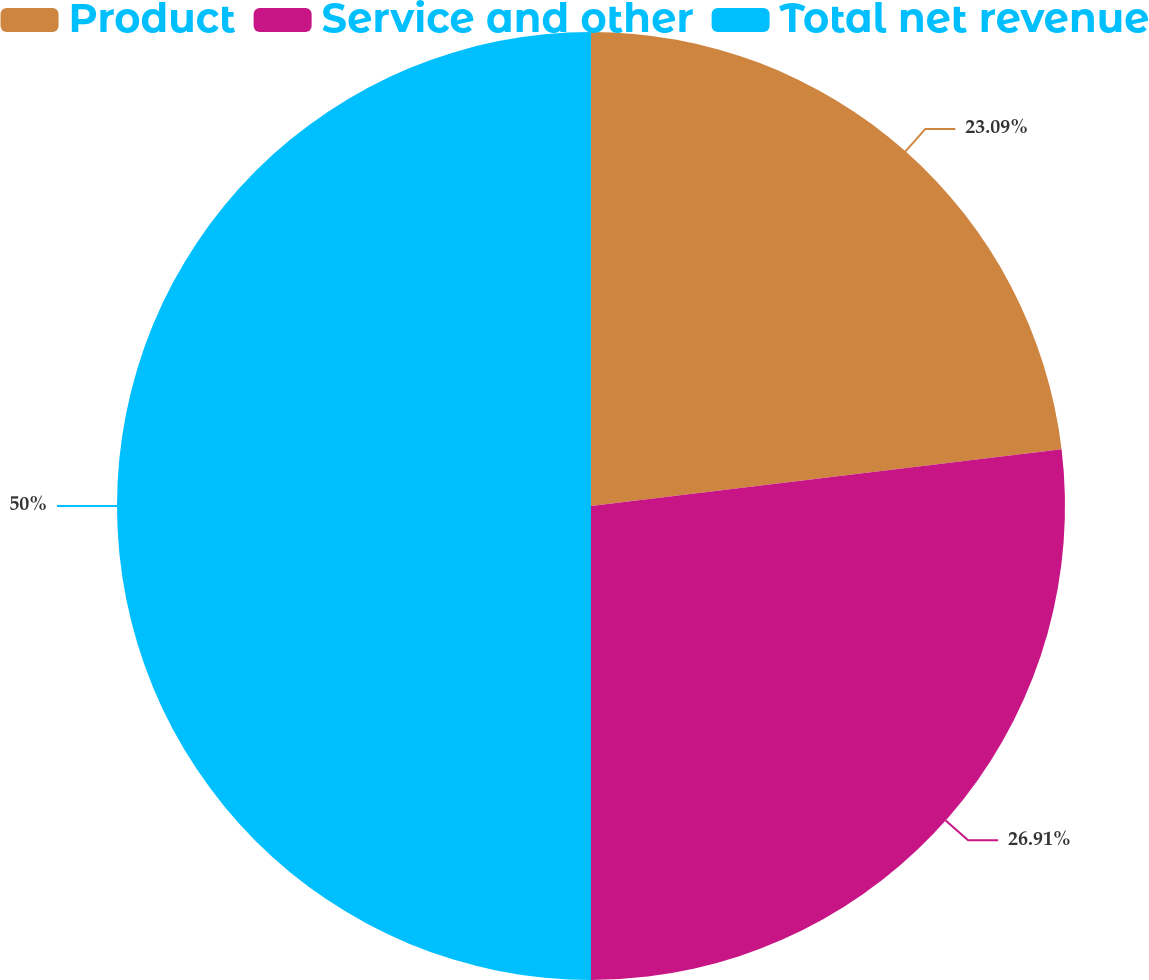Convert chart to OTSL. <chart><loc_0><loc_0><loc_500><loc_500><pie_chart><fcel>Product<fcel>Service and other<fcel>Total net revenue<nl><fcel>23.09%<fcel>26.91%<fcel>50.0%<nl></chart> 